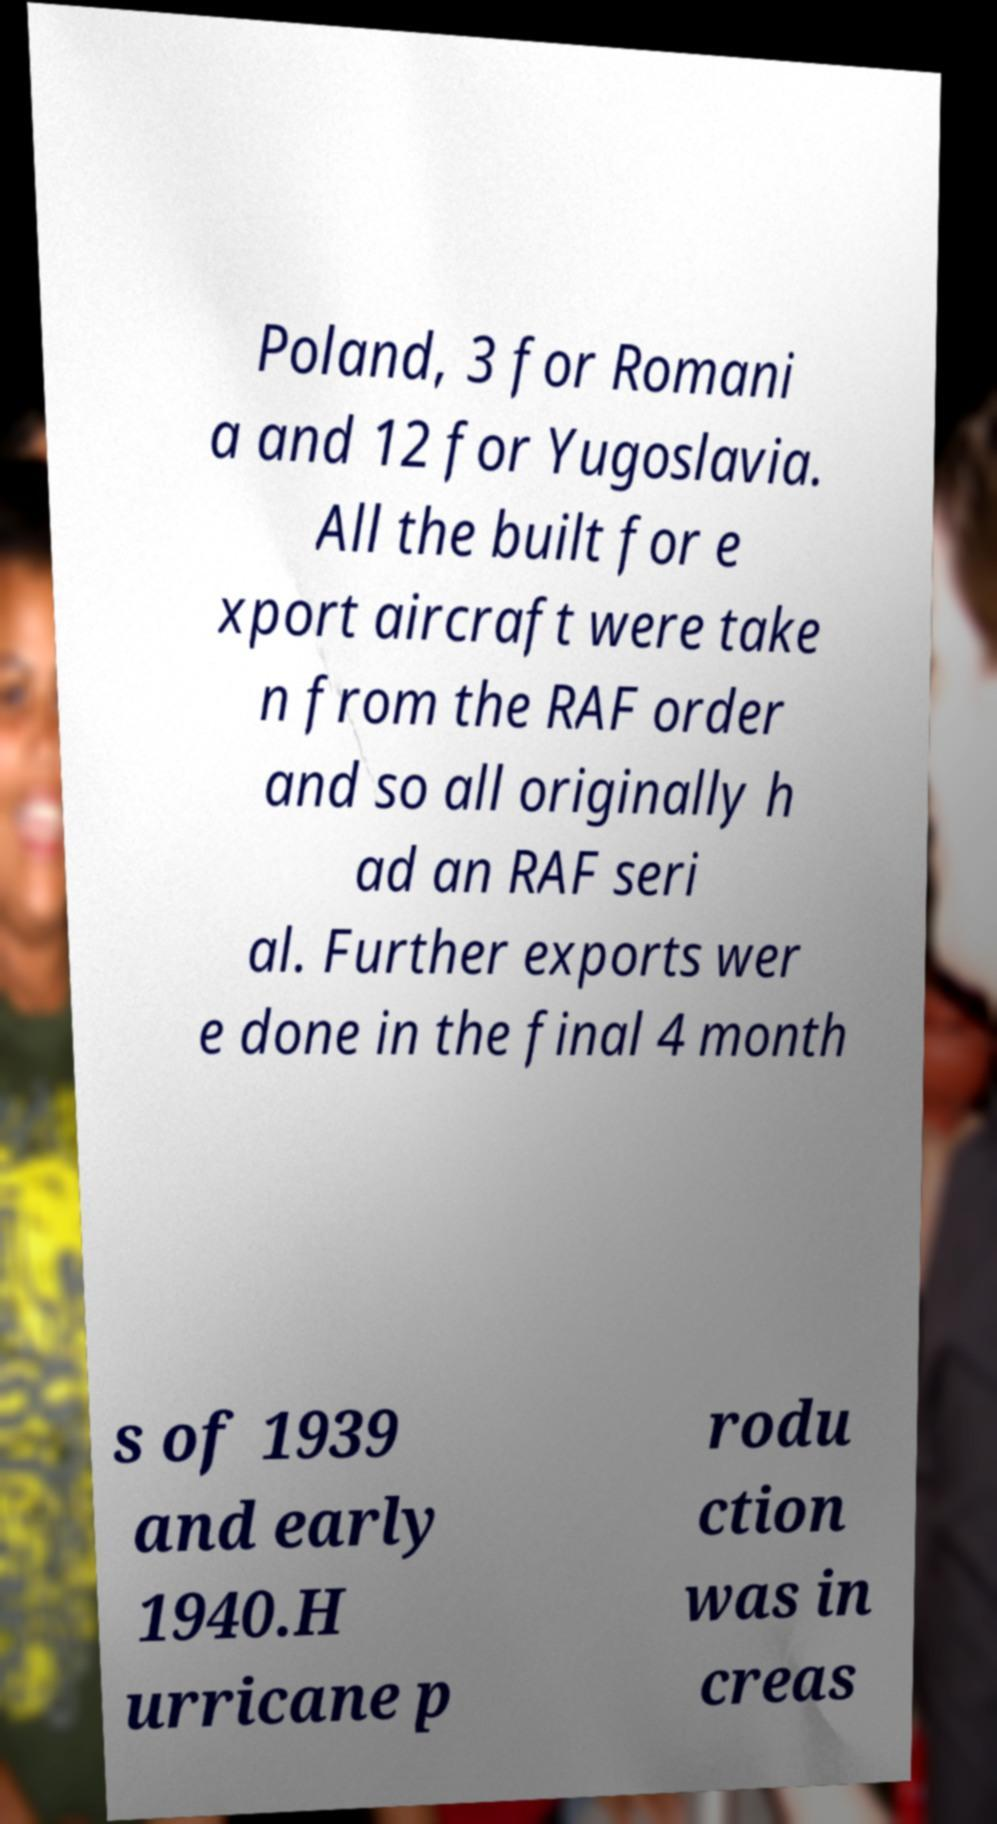I need the written content from this picture converted into text. Can you do that? Poland, 3 for Romani a and 12 for Yugoslavia. All the built for e xport aircraft were take n from the RAF order and so all originally h ad an RAF seri al. Further exports wer e done in the final 4 month s of 1939 and early 1940.H urricane p rodu ction was in creas 